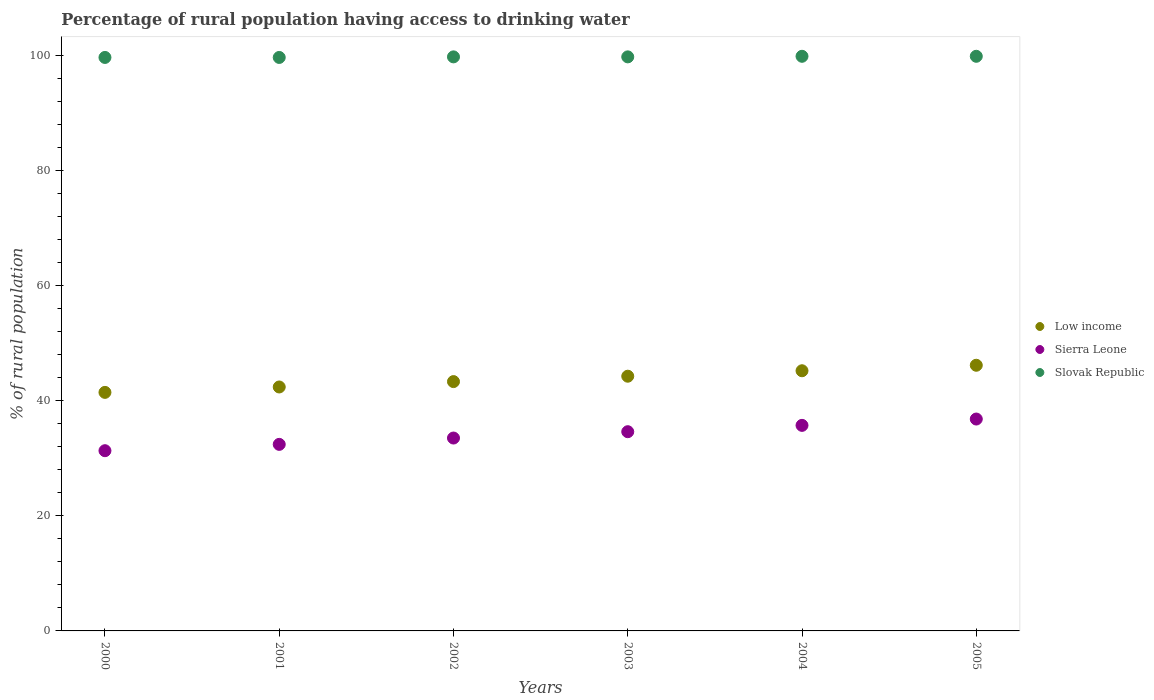Is the number of dotlines equal to the number of legend labels?
Provide a short and direct response. Yes. What is the percentage of rural population having access to drinking water in Slovak Republic in 2005?
Offer a terse response. 99.8. Across all years, what is the maximum percentage of rural population having access to drinking water in Slovak Republic?
Keep it short and to the point. 99.8. Across all years, what is the minimum percentage of rural population having access to drinking water in Sierra Leone?
Your response must be concise. 31.3. In which year was the percentage of rural population having access to drinking water in Sierra Leone minimum?
Provide a succinct answer. 2000. What is the total percentage of rural population having access to drinking water in Sierra Leone in the graph?
Ensure brevity in your answer.  204.3. What is the difference between the percentage of rural population having access to drinking water in Low income in 2000 and that in 2004?
Your response must be concise. -3.76. What is the difference between the percentage of rural population having access to drinking water in Sierra Leone in 2002 and the percentage of rural population having access to drinking water in Low income in 2000?
Provide a short and direct response. -7.93. What is the average percentage of rural population having access to drinking water in Sierra Leone per year?
Provide a succinct answer. 34.05. In the year 2003, what is the difference between the percentage of rural population having access to drinking water in Slovak Republic and percentage of rural population having access to drinking water in Low income?
Your answer should be very brief. 55.46. In how many years, is the percentage of rural population having access to drinking water in Slovak Republic greater than 92 %?
Provide a succinct answer. 6. What is the ratio of the percentage of rural population having access to drinking water in Sierra Leone in 2002 to that in 2005?
Offer a terse response. 0.91. Is the difference between the percentage of rural population having access to drinking water in Slovak Republic in 2003 and 2004 greater than the difference between the percentage of rural population having access to drinking water in Low income in 2003 and 2004?
Make the answer very short. Yes. What is the difference between the highest and the second highest percentage of rural population having access to drinking water in Sierra Leone?
Offer a terse response. 1.1. What is the difference between the highest and the lowest percentage of rural population having access to drinking water in Low income?
Your answer should be very brief. 4.71. Is the sum of the percentage of rural population having access to drinking water in Slovak Republic in 2003 and 2004 greater than the maximum percentage of rural population having access to drinking water in Low income across all years?
Offer a very short reply. Yes. Is it the case that in every year, the sum of the percentage of rural population having access to drinking water in Slovak Republic and percentage of rural population having access to drinking water in Sierra Leone  is greater than the percentage of rural population having access to drinking water in Low income?
Ensure brevity in your answer.  Yes. Does the percentage of rural population having access to drinking water in Low income monotonically increase over the years?
Provide a succinct answer. Yes. Is the percentage of rural population having access to drinking water in Slovak Republic strictly greater than the percentage of rural population having access to drinking water in Sierra Leone over the years?
Offer a very short reply. Yes. Is the percentage of rural population having access to drinking water in Slovak Republic strictly less than the percentage of rural population having access to drinking water in Low income over the years?
Ensure brevity in your answer.  No. How many years are there in the graph?
Keep it short and to the point. 6. Does the graph contain any zero values?
Your response must be concise. No. Where does the legend appear in the graph?
Make the answer very short. Center right. What is the title of the graph?
Keep it short and to the point. Percentage of rural population having access to drinking water. Does "Iceland" appear as one of the legend labels in the graph?
Keep it short and to the point. No. What is the label or title of the Y-axis?
Ensure brevity in your answer.  % of rural population. What is the % of rural population of Low income in 2000?
Give a very brief answer. 41.43. What is the % of rural population of Sierra Leone in 2000?
Offer a terse response. 31.3. What is the % of rural population of Slovak Republic in 2000?
Your response must be concise. 99.6. What is the % of rural population in Low income in 2001?
Offer a terse response. 42.37. What is the % of rural population of Sierra Leone in 2001?
Give a very brief answer. 32.4. What is the % of rural population in Slovak Republic in 2001?
Provide a short and direct response. 99.6. What is the % of rural population of Low income in 2002?
Ensure brevity in your answer.  43.3. What is the % of rural population in Sierra Leone in 2002?
Your answer should be compact. 33.5. What is the % of rural population of Slovak Republic in 2002?
Provide a short and direct response. 99.7. What is the % of rural population of Low income in 2003?
Make the answer very short. 44.24. What is the % of rural population in Sierra Leone in 2003?
Provide a succinct answer. 34.6. What is the % of rural population of Slovak Republic in 2003?
Your answer should be very brief. 99.7. What is the % of rural population in Low income in 2004?
Your answer should be very brief. 45.18. What is the % of rural population in Sierra Leone in 2004?
Ensure brevity in your answer.  35.7. What is the % of rural population in Slovak Republic in 2004?
Your answer should be compact. 99.8. What is the % of rural population in Low income in 2005?
Provide a short and direct response. 46.14. What is the % of rural population of Sierra Leone in 2005?
Keep it short and to the point. 36.8. What is the % of rural population of Slovak Republic in 2005?
Offer a very short reply. 99.8. Across all years, what is the maximum % of rural population in Low income?
Make the answer very short. 46.14. Across all years, what is the maximum % of rural population of Sierra Leone?
Your answer should be very brief. 36.8. Across all years, what is the maximum % of rural population of Slovak Republic?
Make the answer very short. 99.8. Across all years, what is the minimum % of rural population of Low income?
Make the answer very short. 41.43. Across all years, what is the minimum % of rural population in Sierra Leone?
Make the answer very short. 31.3. Across all years, what is the minimum % of rural population of Slovak Republic?
Provide a short and direct response. 99.6. What is the total % of rural population in Low income in the graph?
Your answer should be compact. 262.66. What is the total % of rural population of Sierra Leone in the graph?
Keep it short and to the point. 204.3. What is the total % of rural population in Slovak Republic in the graph?
Your answer should be very brief. 598.2. What is the difference between the % of rural population of Low income in 2000 and that in 2001?
Your answer should be compact. -0.94. What is the difference between the % of rural population of Sierra Leone in 2000 and that in 2001?
Your answer should be very brief. -1.1. What is the difference between the % of rural population in Low income in 2000 and that in 2002?
Offer a very short reply. -1.87. What is the difference between the % of rural population in Slovak Republic in 2000 and that in 2002?
Offer a terse response. -0.1. What is the difference between the % of rural population of Low income in 2000 and that in 2003?
Your answer should be compact. -2.81. What is the difference between the % of rural population in Sierra Leone in 2000 and that in 2003?
Keep it short and to the point. -3.3. What is the difference between the % of rural population in Slovak Republic in 2000 and that in 2003?
Keep it short and to the point. -0.1. What is the difference between the % of rural population in Low income in 2000 and that in 2004?
Provide a short and direct response. -3.76. What is the difference between the % of rural population in Low income in 2000 and that in 2005?
Give a very brief answer. -4.71. What is the difference between the % of rural population of Sierra Leone in 2000 and that in 2005?
Your answer should be compact. -5.5. What is the difference between the % of rural population in Slovak Republic in 2000 and that in 2005?
Offer a very short reply. -0.2. What is the difference between the % of rural population of Low income in 2001 and that in 2002?
Your answer should be compact. -0.94. What is the difference between the % of rural population of Slovak Republic in 2001 and that in 2002?
Make the answer very short. -0.1. What is the difference between the % of rural population of Low income in 2001 and that in 2003?
Offer a very short reply. -1.87. What is the difference between the % of rural population in Sierra Leone in 2001 and that in 2003?
Provide a short and direct response. -2.2. What is the difference between the % of rural population in Low income in 2001 and that in 2004?
Provide a succinct answer. -2.82. What is the difference between the % of rural population in Low income in 2001 and that in 2005?
Offer a very short reply. -3.77. What is the difference between the % of rural population in Sierra Leone in 2001 and that in 2005?
Ensure brevity in your answer.  -4.4. What is the difference between the % of rural population in Slovak Republic in 2001 and that in 2005?
Offer a very short reply. -0.2. What is the difference between the % of rural population of Low income in 2002 and that in 2003?
Make the answer very short. -0.94. What is the difference between the % of rural population of Low income in 2002 and that in 2004?
Your answer should be compact. -1.88. What is the difference between the % of rural population of Low income in 2002 and that in 2005?
Offer a terse response. -2.84. What is the difference between the % of rural population of Sierra Leone in 2002 and that in 2005?
Offer a very short reply. -3.3. What is the difference between the % of rural population in Low income in 2003 and that in 2004?
Your answer should be very brief. -0.95. What is the difference between the % of rural population of Sierra Leone in 2003 and that in 2004?
Offer a terse response. -1.1. What is the difference between the % of rural population of Low income in 2003 and that in 2005?
Your answer should be very brief. -1.9. What is the difference between the % of rural population in Sierra Leone in 2003 and that in 2005?
Offer a terse response. -2.2. What is the difference between the % of rural population of Slovak Republic in 2003 and that in 2005?
Offer a terse response. -0.1. What is the difference between the % of rural population of Low income in 2004 and that in 2005?
Your response must be concise. -0.95. What is the difference between the % of rural population of Sierra Leone in 2004 and that in 2005?
Your answer should be compact. -1.1. What is the difference between the % of rural population in Low income in 2000 and the % of rural population in Sierra Leone in 2001?
Your answer should be compact. 9.03. What is the difference between the % of rural population in Low income in 2000 and the % of rural population in Slovak Republic in 2001?
Provide a succinct answer. -58.17. What is the difference between the % of rural population of Sierra Leone in 2000 and the % of rural population of Slovak Republic in 2001?
Offer a terse response. -68.3. What is the difference between the % of rural population of Low income in 2000 and the % of rural population of Sierra Leone in 2002?
Your answer should be very brief. 7.93. What is the difference between the % of rural population in Low income in 2000 and the % of rural population in Slovak Republic in 2002?
Your response must be concise. -58.27. What is the difference between the % of rural population in Sierra Leone in 2000 and the % of rural population in Slovak Republic in 2002?
Your answer should be compact. -68.4. What is the difference between the % of rural population of Low income in 2000 and the % of rural population of Sierra Leone in 2003?
Your answer should be compact. 6.83. What is the difference between the % of rural population in Low income in 2000 and the % of rural population in Slovak Republic in 2003?
Ensure brevity in your answer.  -58.27. What is the difference between the % of rural population in Sierra Leone in 2000 and the % of rural population in Slovak Republic in 2003?
Keep it short and to the point. -68.4. What is the difference between the % of rural population in Low income in 2000 and the % of rural population in Sierra Leone in 2004?
Provide a succinct answer. 5.73. What is the difference between the % of rural population of Low income in 2000 and the % of rural population of Slovak Republic in 2004?
Your response must be concise. -58.37. What is the difference between the % of rural population in Sierra Leone in 2000 and the % of rural population in Slovak Republic in 2004?
Provide a succinct answer. -68.5. What is the difference between the % of rural population of Low income in 2000 and the % of rural population of Sierra Leone in 2005?
Your answer should be very brief. 4.63. What is the difference between the % of rural population in Low income in 2000 and the % of rural population in Slovak Republic in 2005?
Offer a very short reply. -58.37. What is the difference between the % of rural population of Sierra Leone in 2000 and the % of rural population of Slovak Republic in 2005?
Offer a very short reply. -68.5. What is the difference between the % of rural population in Low income in 2001 and the % of rural population in Sierra Leone in 2002?
Ensure brevity in your answer.  8.87. What is the difference between the % of rural population of Low income in 2001 and the % of rural population of Slovak Republic in 2002?
Your answer should be very brief. -57.33. What is the difference between the % of rural population of Sierra Leone in 2001 and the % of rural population of Slovak Republic in 2002?
Provide a succinct answer. -67.3. What is the difference between the % of rural population of Low income in 2001 and the % of rural population of Sierra Leone in 2003?
Your answer should be compact. 7.77. What is the difference between the % of rural population in Low income in 2001 and the % of rural population in Slovak Republic in 2003?
Your response must be concise. -57.33. What is the difference between the % of rural population of Sierra Leone in 2001 and the % of rural population of Slovak Republic in 2003?
Provide a short and direct response. -67.3. What is the difference between the % of rural population in Low income in 2001 and the % of rural population in Sierra Leone in 2004?
Your answer should be very brief. 6.67. What is the difference between the % of rural population of Low income in 2001 and the % of rural population of Slovak Republic in 2004?
Offer a terse response. -57.43. What is the difference between the % of rural population of Sierra Leone in 2001 and the % of rural population of Slovak Republic in 2004?
Your answer should be compact. -67.4. What is the difference between the % of rural population in Low income in 2001 and the % of rural population in Sierra Leone in 2005?
Your answer should be compact. 5.57. What is the difference between the % of rural population in Low income in 2001 and the % of rural population in Slovak Republic in 2005?
Your answer should be compact. -57.43. What is the difference between the % of rural population of Sierra Leone in 2001 and the % of rural population of Slovak Republic in 2005?
Give a very brief answer. -67.4. What is the difference between the % of rural population in Low income in 2002 and the % of rural population in Sierra Leone in 2003?
Make the answer very short. 8.7. What is the difference between the % of rural population in Low income in 2002 and the % of rural population in Slovak Republic in 2003?
Give a very brief answer. -56.4. What is the difference between the % of rural population of Sierra Leone in 2002 and the % of rural population of Slovak Republic in 2003?
Your answer should be compact. -66.2. What is the difference between the % of rural population of Low income in 2002 and the % of rural population of Sierra Leone in 2004?
Your answer should be very brief. 7.6. What is the difference between the % of rural population of Low income in 2002 and the % of rural population of Slovak Republic in 2004?
Ensure brevity in your answer.  -56.5. What is the difference between the % of rural population in Sierra Leone in 2002 and the % of rural population in Slovak Republic in 2004?
Your answer should be compact. -66.3. What is the difference between the % of rural population of Low income in 2002 and the % of rural population of Sierra Leone in 2005?
Provide a short and direct response. 6.5. What is the difference between the % of rural population of Low income in 2002 and the % of rural population of Slovak Republic in 2005?
Your answer should be very brief. -56.5. What is the difference between the % of rural population of Sierra Leone in 2002 and the % of rural population of Slovak Republic in 2005?
Keep it short and to the point. -66.3. What is the difference between the % of rural population in Low income in 2003 and the % of rural population in Sierra Leone in 2004?
Give a very brief answer. 8.54. What is the difference between the % of rural population of Low income in 2003 and the % of rural population of Slovak Republic in 2004?
Keep it short and to the point. -55.56. What is the difference between the % of rural population in Sierra Leone in 2003 and the % of rural population in Slovak Republic in 2004?
Offer a terse response. -65.2. What is the difference between the % of rural population in Low income in 2003 and the % of rural population in Sierra Leone in 2005?
Your response must be concise. 7.44. What is the difference between the % of rural population of Low income in 2003 and the % of rural population of Slovak Republic in 2005?
Offer a terse response. -55.56. What is the difference between the % of rural population of Sierra Leone in 2003 and the % of rural population of Slovak Republic in 2005?
Provide a short and direct response. -65.2. What is the difference between the % of rural population of Low income in 2004 and the % of rural population of Sierra Leone in 2005?
Provide a succinct answer. 8.38. What is the difference between the % of rural population of Low income in 2004 and the % of rural population of Slovak Republic in 2005?
Make the answer very short. -54.62. What is the difference between the % of rural population of Sierra Leone in 2004 and the % of rural population of Slovak Republic in 2005?
Your response must be concise. -64.1. What is the average % of rural population in Low income per year?
Offer a terse response. 43.78. What is the average % of rural population of Sierra Leone per year?
Make the answer very short. 34.05. What is the average % of rural population of Slovak Republic per year?
Provide a succinct answer. 99.7. In the year 2000, what is the difference between the % of rural population in Low income and % of rural population in Sierra Leone?
Make the answer very short. 10.13. In the year 2000, what is the difference between the % of rural population of Low income and % of rural population of Slovak Republic?
Ensure brevity in your answer.  -58.17. In the year 2000, what is the difference between the % of rural population of Sierra Leone and % of rural population of Slovak Republic?
Offer a terse response. -68.3. In the year 2001, what is the difference between the % of rural population of Low income and % of rural population of Sierra Leone?
Your response must be concise. 9.97. In the year 2001, what is the difference between the % of rural population in Low income and % of rural population in Slovak Republic?
Provide a short and direct response. -57.23. In the year 2001, what is the difference between the % of rural population of Sierra Leone and % of rural population of Slovak Republic?
Offer a very short reply. -67.2. In the year 2002, what is the difference between the % of rural population of Low income and % of rural population of Sierra Leone?
Offer a terse response. 9.8. In the year 2002, what is the difference between the % of rural population of Low income and % of rural population of Slovak Republic?
Provide a short and direct response. -56.4. In the year 2002, what is the difference between the % of rural population in Sierra Leone and % of rural population in Slovak Republic?
Offer a very short reply. -66.2. In the year 2003, what is the difference between the % of rural population of Low income and % of rural population of Sierra Leone?
Make the answer very short. 9.64. In the year 2003, what is the difference between the % of rural population of Low income and % of rural population of Slovak Republic?
Provide a succinct answer. -55.46. In the year 2003, what is the difference between the % of rural population of Sierra Leone and % of rural population of Slovak Republic?
Give a very brief answer. -65.1. In the year 2004, what is the difference between the % of rural population of Low income and % of rural population of Sierra Leone?
Offer a terse response. 9.48. In the year 2004, what is the difference between the % of rural population of Low income and % of rural population of Slovak Republic?
Your answer should be compact. -54.62. In the year 2004, what is the difference between the % of rural population of Sierra Leone and % of rural population of Slovak Republic?
Your answer should be very brief. -64.1. In the year 2005, what is the difference between the % of rural population of Low income and % of rural population of Sierra Leone?
Your answer should be compact. 9.34. In the year 2005, what is the difference between the % of rural population in Low income and % of rural population in Slovak Republic?
Ensure brevity in your answer.  -53.66. In the year 2005, what is the difference between the % of rural population in Sierra Leone and % of rural population in Slovak Republic?
Offer a terse response. -63. What is the ratio of the % of rural population of Low income in 2000 to that in 2001?
Offer a terse response. 0.98. What is the ratio of the % of rural population of Sierra Leone in 2000 to that in 2001?
Keep it short and to the point. 0.97. What is the ratio of the % of rural population in Slovak Republic in 2000 to that in 2001?
Your response must be concise. 1. What is the ratio of the % of rural population of Low income in 2000 to that in 2002?
Offer a terse response. 0.96. What is the ratio of the % of rural population in Sierra Leone in 2000 to that in 2002?
Your answer should be very brief. 0.93. What is the ratio of the % of rural population of Low income in 2000 to that in 2003?
Your response must be concise. 0.94. What is the ratio of the % of rural population of Sierra Leone in 2000 to that in 2003?
Keep it short and to the point. 0.9. What is the ratio of the % of rural population in Low income in 2000 to that in 2004?
Give a very brief answer. 0.92. What is the ratio of the % of rural population of Sierra Leone in 2000 to that in 2004?
Your answer should be compact. 0.88. What is the ratio of the % of rural population of Low income in 2000 to that in 2005?
Provide a succinct answer. 0.9. What is the ratio of the % of rural population in Sierra Leone in 2000 to that in 2005?
Give a very brief answer. 0.85. What is the ratio of the % of rural population of Slovak Republic in 2000 to that in 2005?
Offer a very short reply. 1. What is the ratio of the % of rural population in Low income in 2001 to that in 2002?
Your answer should be compact. 0.98. What is the ratio of the % of rural population of Sierra Leone in 2001 to that in 2002?
Offer a terse response. 0.97. What is the ratio of the % of rural population of Low income in 2001 to that in 2003?
Provide a short and direct response. 0.96. What is the ratio of the % of rural population of Sierra Leone in 2001 to that in 2003?
Offer a very short reply. 0.94. What is the ratio of the % of rural population of Low income in 2001 to that in 2004?
Your answer should be compact. 0.94. What is the ratio of the % of rural population of Sierra Leone in 2001 to that in 2004?
Your answer should be very brief. 0.91. What is the ratio of the % of rural population of Low income in 2001 to that in 2005?
Make the answer very short. 0.92. What is the ratio of the % of rural population of Sierra Leone in 2001 to that in 2005?
Your answer should be compact. 0.88. What is the ratio of the % of rural population in Low income in 2002 to that in 2003?
Give a very brief answer. 0.98. What is the ratio of the % of rural population of Sierra Leone in 2002 to that in 2003?
Keep it short and to the point. 0.97. What is the ratio of the % of rural population of Low income in 2002 to that in 2004?
Your answer should be very brief. 0.96. What is the ratio of the % of rural population in Sierra Leone in 2002 to that in 2004?
Your answer should be compact. 0.94. What is the ratio of the % of rural population in Slovak Republic in 2002 to that in 2004?
Your answer should be compact. 1. What is the ratio of the % of rural population of Low income in 2002 to that in 2005?
Give a very brief answer. 0.94. What is the ratio of the % of rural population in Sierra Leone in 2002 to that in 2005?
Provide a short and direct response. 0.91. What is the ratio of the % of rural population in Slovak Republic in 2002 to that in 2005?
Provide a short and direct response. 1. What is the ratio of the % of rural population in Low income in 2003 to that in 2004?
Your response must be concise. 0.98. What is the ratio of the % of rural population of Sierra Leone in 2003 to that in 2004?
Your response must be concise. 0.97. What is the ratio of the % of rural population in Low income in 2003 to that in 2005?
Provide a succinct answer. 0.96. What is the ratio of the % of rural population in Sierra Leone in 2003 to that in 2005?
Your answer should be very brief. 0.94. What is the ratio of the % of rural population of Slovak Republic in 2003 to that in 2005?
Provide a short and direct response. 1. What is the ratio of the % of rural population of Low income in 2004 to that in 2005?
Ensure brevity in your answer.  0.98. What is the ratio of the % of rural population in Sierra Leone in 2004 to that in 2005?
Your response must be concise. 0.97. What is the difference between the highest and the second highest % of rural population in Low income?
Provide a succinct answer. 0.95. What is the difference between the highest and the second highest % of rural population of Sierra Leone?
Make the answer very short. 1.1. What is the difference between the highest and the lowest % of rural population in Low income?
Ensure brevity in your answer.  4.71. What is the difference between the highest and the lowest % of rural population of Slovak Republic?
Provide a short and direct response. 0.2. 